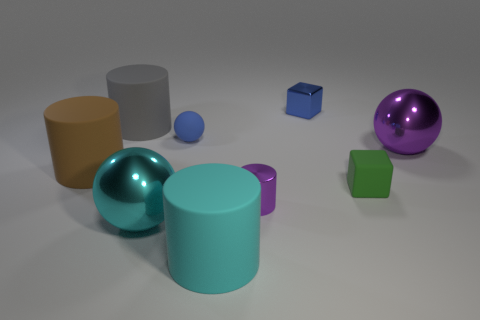What is the material of the purple thing in front of the big sphere right of the small matte object in front of the big purple sphere?
Provide a short and direct response. Metal. Is the big cyan object that is to the right of the small blue rubber thing made of the same material as the ball in front of the small cylinder?
Provide a short and direct response. No. There is a matte cylinder that is in front of the purple shiny sphere and left of the cyan rubber thing; what size is it?
Offer a very short reply. Large. There is a cyan cylinder that is the same size as the gray thing; what material is it?
Give a very brief answer. Rubber. How many purple spheres are left of the metal thing that is behind the large metallic thing behind the large brown matte thing?
Provide a succinct answer. 0. Do the small matte thing to the right of the shiny block and the sphere that is right of the small ball have the same color?
Provide a short and direct response. No. There is a thing that is both on the right side of the big cyan matte cylinder and in front of the small green block; what color is it?
Your answer should be very brief. Purple. How many purple shiny cylinders are the same size as the brown matte cylinder?
Your answer should be very brief. 0. What shape is the large rubber thing behind the shiny ball that is right of the big cyan matte cylinder?
Provide a short and direct response. Cylinder. There is a large shiny object on the right side of the metallic ball that is in front of the ball to the right of the green matte object; what is its shape?
Your answer should be compact. Sphere. 